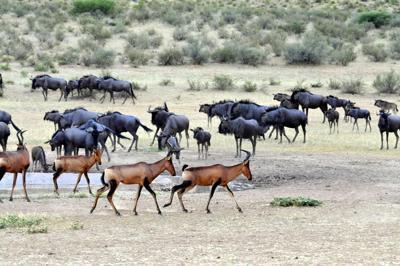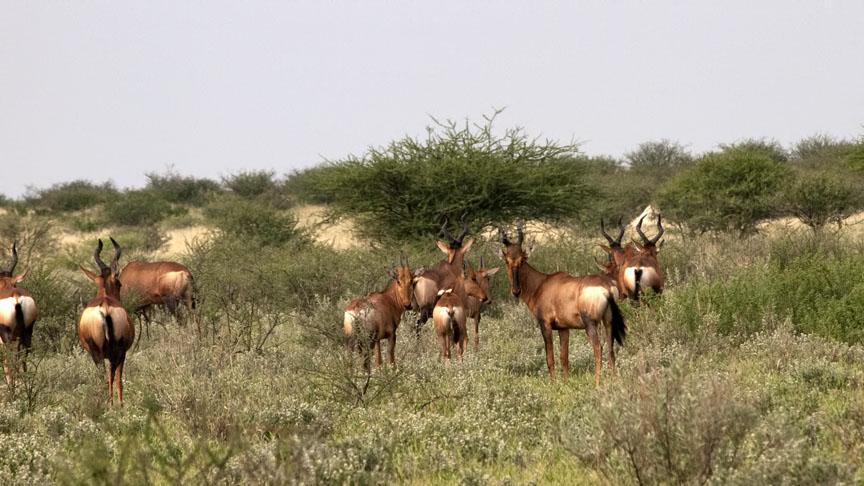The first image is the image on the left, the second image is the image on the right. Assess this claim about the two images: "There are 5 antelopes in the right most image.". Correct or not? Answer yes or no. No. The first image is the image on the left, the second image is the image on the right. Assess this claim about the two images: "An image shows a group of five antelope type animals.". Correct or not? Answer yes or no. No. 